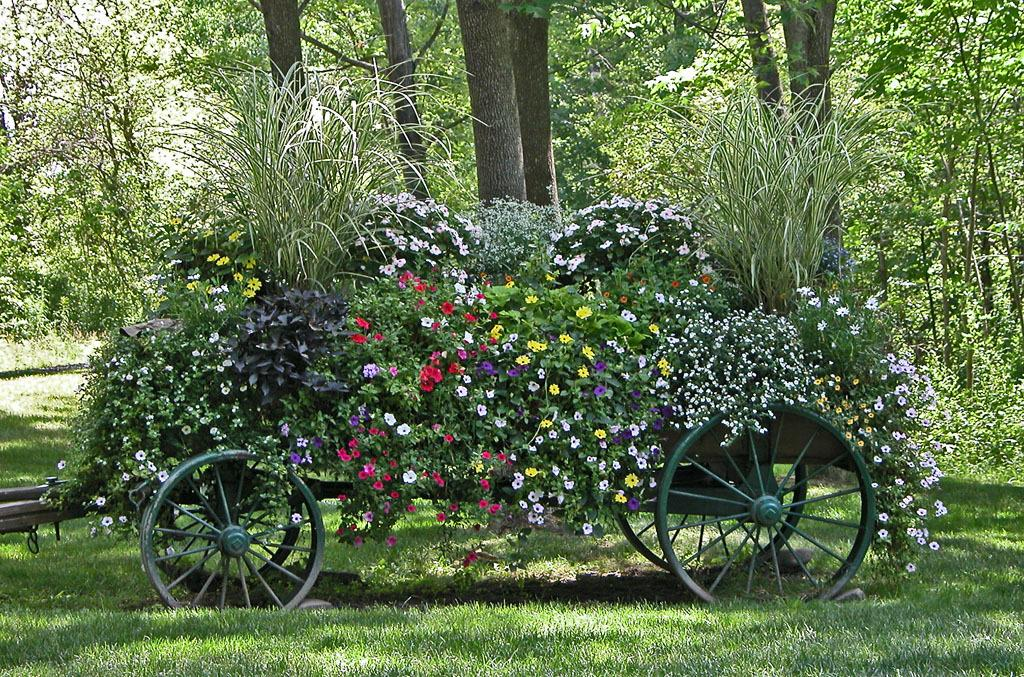What is the main subject in the center of the image? There is a vehicle in the center of the image. What is inside the vehicle? The vehicle contains plants and flowers. What type of natural environment is visible at the bottom of the image? There is grass at the bottom of the image. What can be seen in the background of the image? There are trees in the background of the image. What type of produce is being sold by the visitor in the image? There is no produce or visitor present in the image; it features a vehicle with plants and flowers, grass, and trees in the background. 